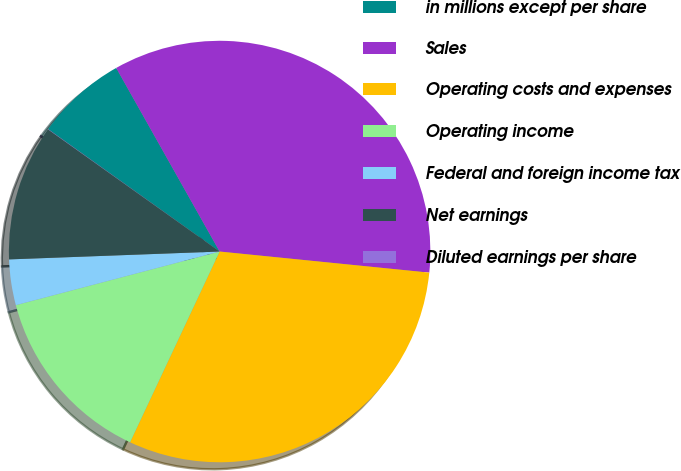Convert chart. <chart><loc_0><loc_0><loc_500><loc_500><pie_chart><fcel>in millions except per share<fcel>Sales<fcel>Operating costs and expenses<fcel>Operating income<fcel>Federal and foreign income tax<fcel>Net earnings<fcel>Diluted earnings per share<nl><fcel>6.97%<fcel>34.76%<fcel>30.39%<fcel>13.92%<fcel>3.5%<fcel>10.44%<fcel>0.02%<nl></chart> 